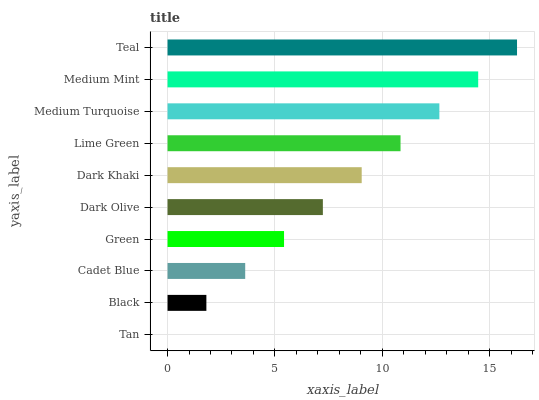Is Tan the minimum?
Answer yes or no. Yes. Is Teal the maximum?
Answer yes or no. Yes. Is Black the minimum?
Answer yes or no. No. Is Black the maximum?
Answer yes or no. No. Is Black greater than Tan?
Answer yes or no. Yes. Is Tan less than Black?
Answer yes or no. Yes. Is Tan greater than Black?
Answer yes or no. No. Is Black less than Tan?
Answer yes or no. No. Is Dark Khaki the high median?
Answer yes or no. Yes. Is Dark Olive the low median?
Answer yes or no. Yes. Is Tan the high median?
Answer yes or no. No. Is Cadet Blue the low median?
Answer yes or no. No. 